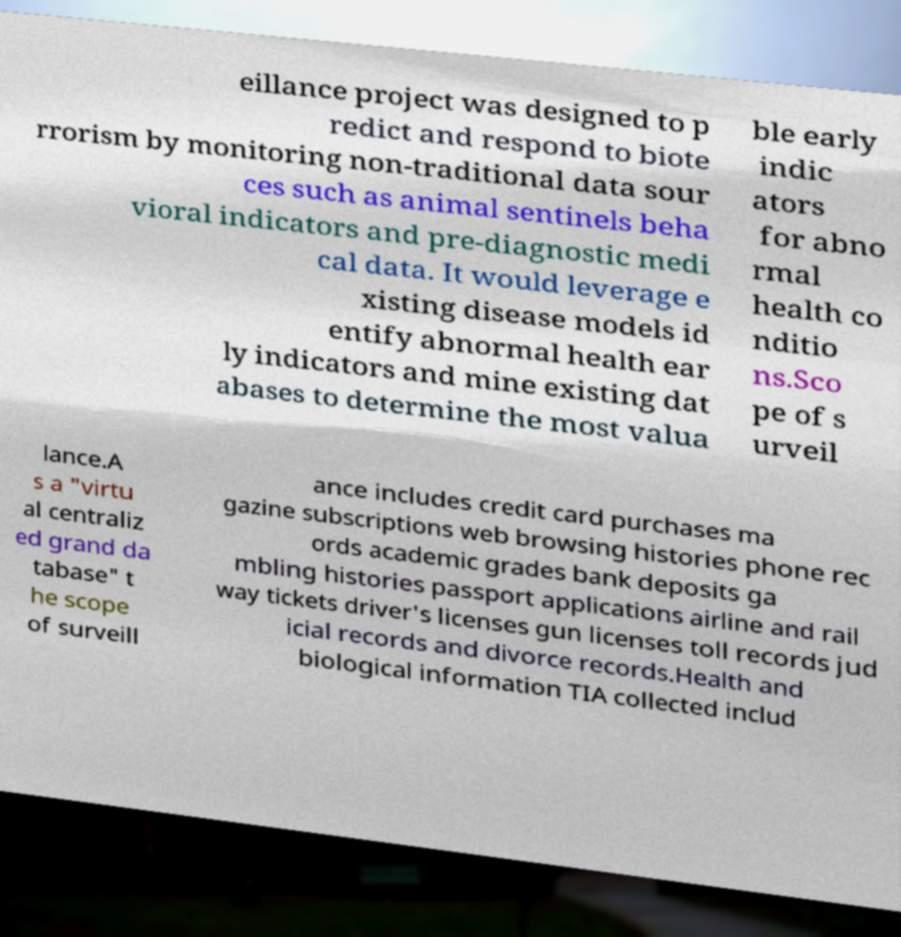Could you extract and type out the text from this image? eillance project was designed to p redict and respond to biote rrorism by monitoring non-traditional data sour ces such as animal sentinels beha vioral indicators and pre-diagnostic medi cal data. It would leverage e xisting disease models id entify abnormal health ear ly indicators and mine existing dat abases to determine the most valua ble early indic ators for abno rmal health co nditio ns.Sco pe of s urveil lance.A s a "virtu al centraliz ed grand da tabase" t he scope of surveill ance includes credit card purchases ma gazine subscriptions web browsing histories phone rec ords academic grades bank deposits ga mbling histories passport applications airline and rail way tickets driver's licenses gun licenses toll records jud icial records and divorce records.Health and biological information TIA collected includ 